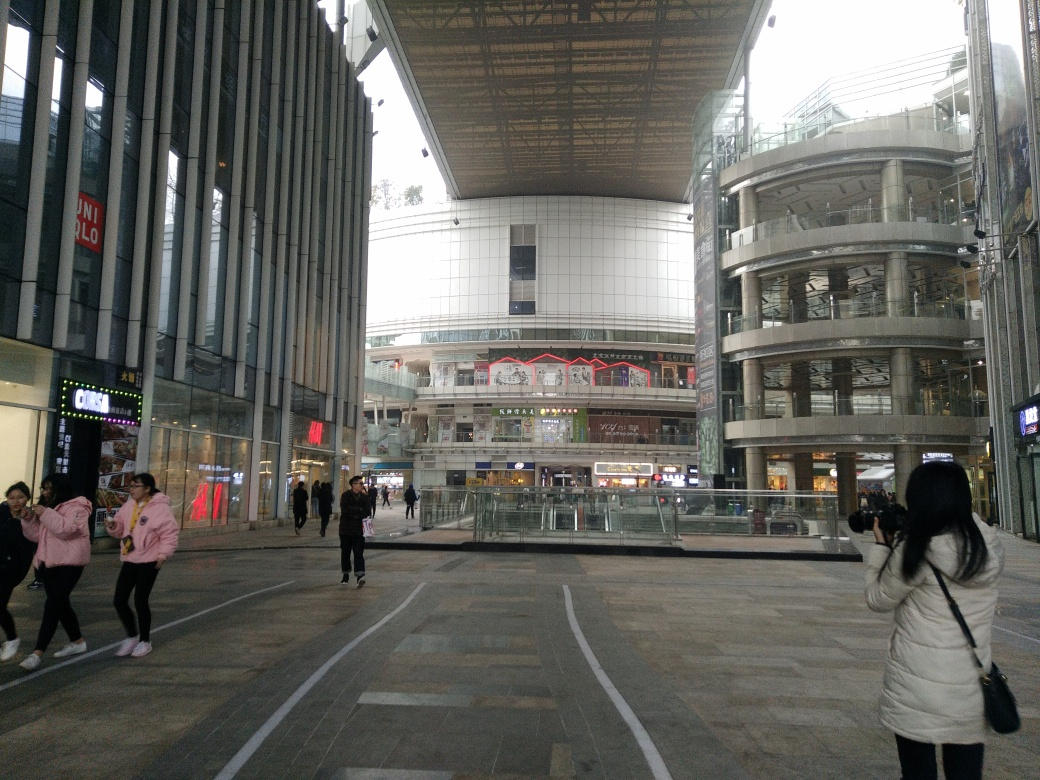Can you describe the architectural style visible in the image? The image showcases a blend of modern architecture characterized by the use of glass, steel, and clean lines that give the buildings a contemporary and somewhat industrial look. This style is typical for commercial and urban developments focused on creating open, functional spaces. 